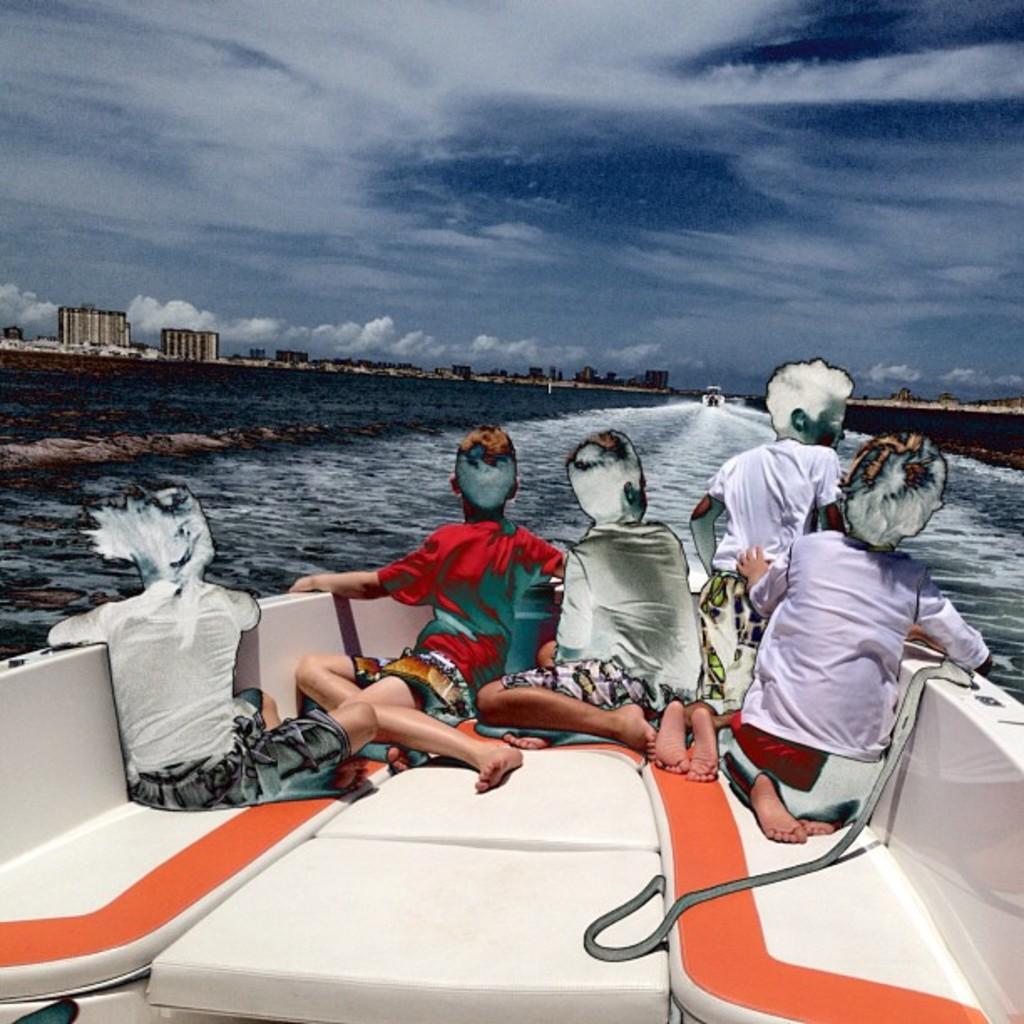How would you summarize this image in a sentence or two? This is an edited image. In the foreground of the picture there are kids sitting in a boat, in front of them there is a water body. In the center of the background there is a boat in the water. In the background there are buildings. 